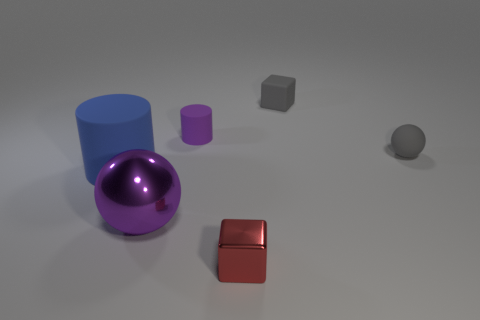Add 3 big blue cylinders. How many objects exist? 9 Subtract all red cubes. How many cubes are left? 1 Subtract all brown spheres. How many red cubes are left? 1 Subtract 1 gray cubes. How many objects are left? 5 Subtract all balls. How many objects are left? 4 Subtract 1 spheres. How many spheres are left? 1 Subtract all green blocks. Subtract all red cylinders. How many blocks are left? 2 Subtract all red metallic objects. Subtract all big green shiny things. How many objects are left? 5 Add 5 tiny gray rubber balls. How many tiny gray rubber balls are left? 6 Add 5 large yellow shiny balls. How many large yellow shiny balls exist? 5 